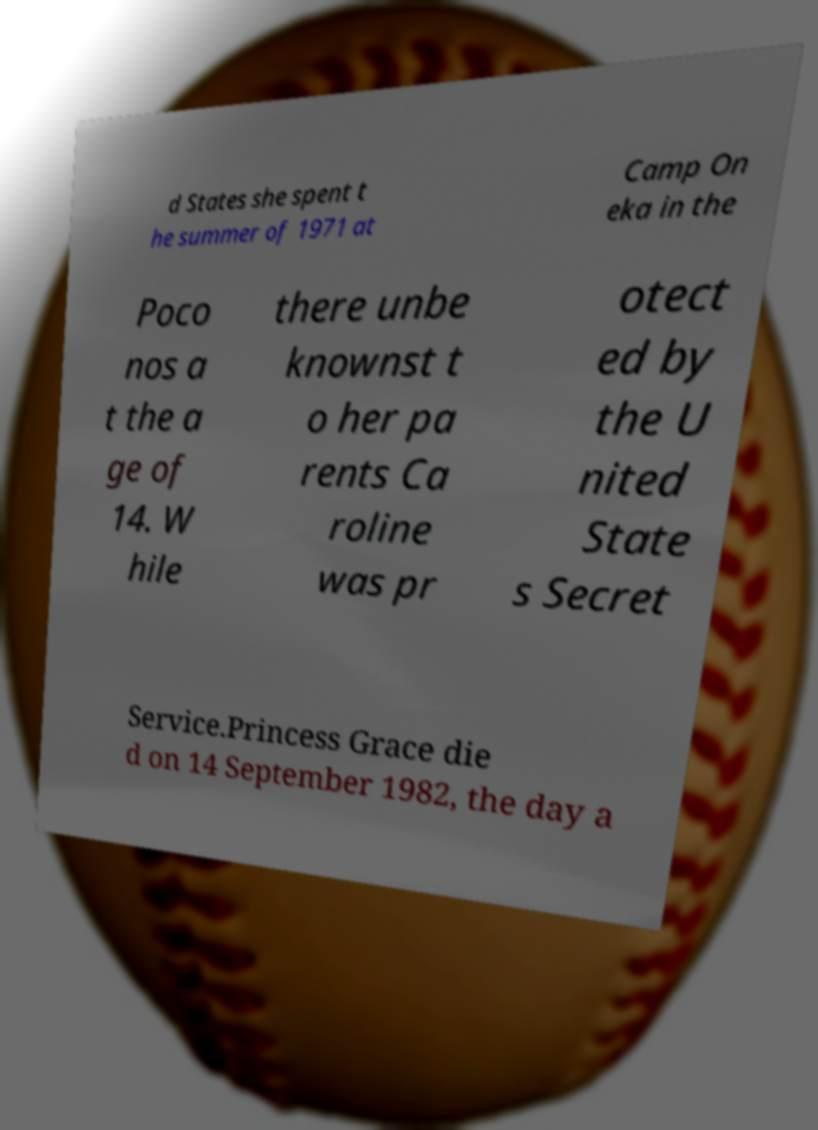Could you assist in decoding the text presented in this image and type it out clearly? d States she spent t he summer of 1971 at Camp On eka in the Poco nos a t the a ge of 14. W hile there unbe knownst t o her pa rents Ca roline was pr otect ed by the U nited State s Secret Service.Princess Grace die d on 14 September 1982, the day a 